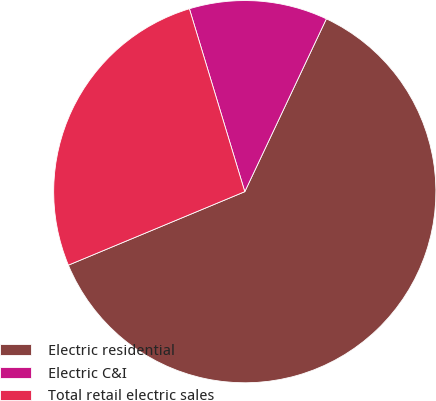<chart> <loc_0><loc_0><loc_500><loc_500><pie_chart><fcel>Electric residential<fcel>Electric C&I<fcel>Total retail electric sales<nl><fcel>61.7%<fcel>11.7%<fcel>26.6%<nl></chart> 